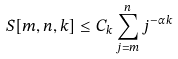Convert formula to latex. <formula><loc_0><loc_0><loc_500><loc_500>S [ m , n , k ] \leq C _ { k } \sum _ { j = m } ^ { n } j ^ { - \alpha k }</formula> 